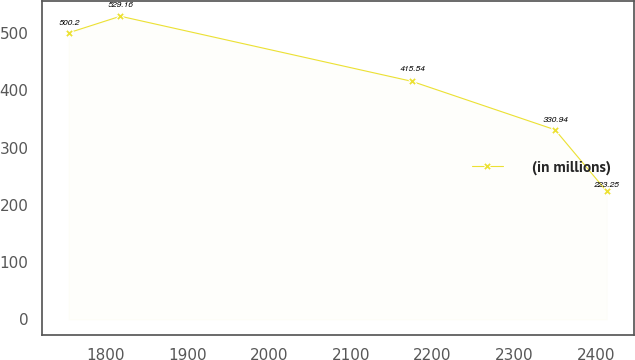<chart> <loc_0><loc_0><loc_500><loc_500><line_chart><ecel><fcel>(in millions)<nl><fcel>1755.11<fcel>500.2<nl><fcel>1818.34<fcel>529.16<nl><fcel>2174.85<fcel>415.54<nl><fcel>2350.09<fcel>330.94<nl><fcel>2413.32<fcel>223.25<nl></chart> 